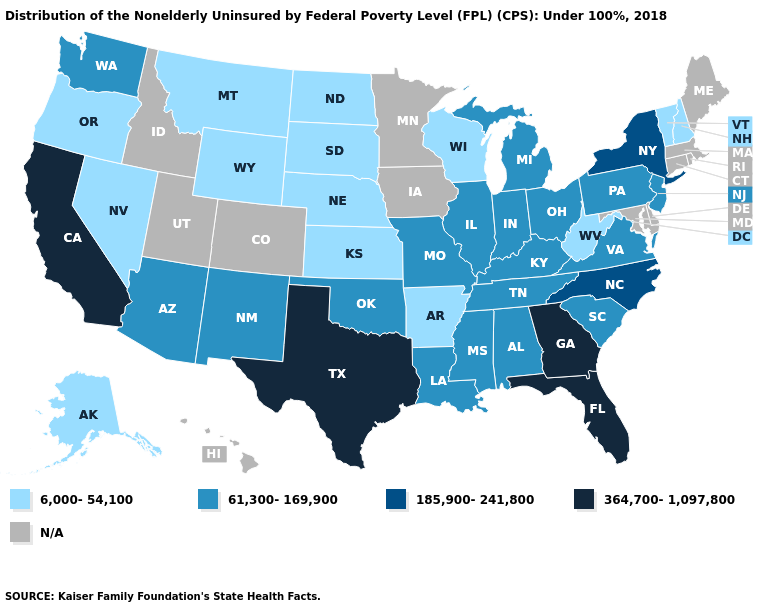Name the states that have a value in the range N/A?
Be succinct. Colorado, Connecticut, Delaware, Hawaii, Idaho, Iowa, Maine, Maryland, Massachusetts, Minnesota, Rhode Island, Utah. Which states have the lowest value in the USA?
Be succinct. Alaska, Arkansas, Kansas, Montana, Nebraska, Nevada, New Hampshire, North Dakota, Oregon, South Dakota, Vermont, West Virginia, Wisconsin, Wyoming. What is the highest value in states that border Nebraska?
Give a very brief answer. 61,300-169,900. How many symbols are there in the legend?
Concise answer only. 5. Does New Hampshire have the lowest value in the USA?
Be succinct. Yes. Does the first symbol in the legend represent the smallest category?
Write a very short answer. Yes. Among the states that border Maine , which have the highest value?
Quick response, please. New Hampshire. What is the lowest value in the MidWest?
Short answer required. 6,000-54,100. Among the states that border Vermont , does New Hampshire have the lowest value?
Keep it brief. Yes. Does North Dakota have the lowest value in the MidWest?
Quick response, please. Yes. What is the value of Ohio?
Quick response, please. 61,300-169,900. Name the states that have a value in the range 61,300-169,900?
Concise answer only. Alabama, Arizona, Illinois, Indiana, Kentucky, Louisiana, Michigan, Mississippi, Missouri, New Jersey, New Mexico, Ohio, Oklahoma, Pennsylvania, South Carolina, Tennessee, Virginia, Washington. Name the states that have a value in the range 364,700-1,097,800?
Short answer required. California, Florida, Georgia, Texas. Does Nebraska have the lowest value in the USA?
Quick response, please. Yes. Does the first symbol in the legend represent the smallest category?
Keep it brief. Yes. 